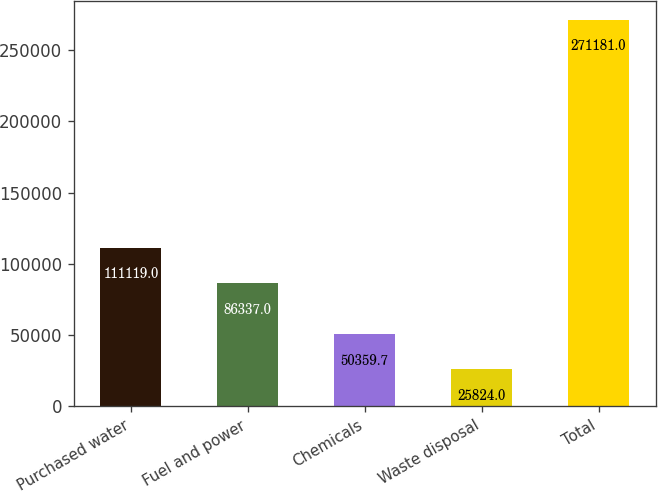Convert chart. <chart><loc_0><loc_0><loc_500><loc_500><bar_chart><fcel>Purchased water<fcel>Fuel and power<fcel>Chemicals<fcel>Waste disposal<fcel>Total<nl><fcel>111119<fcel>86337<fcel>50359.7<fcel>25824<fcel>271181<nl></chart> 